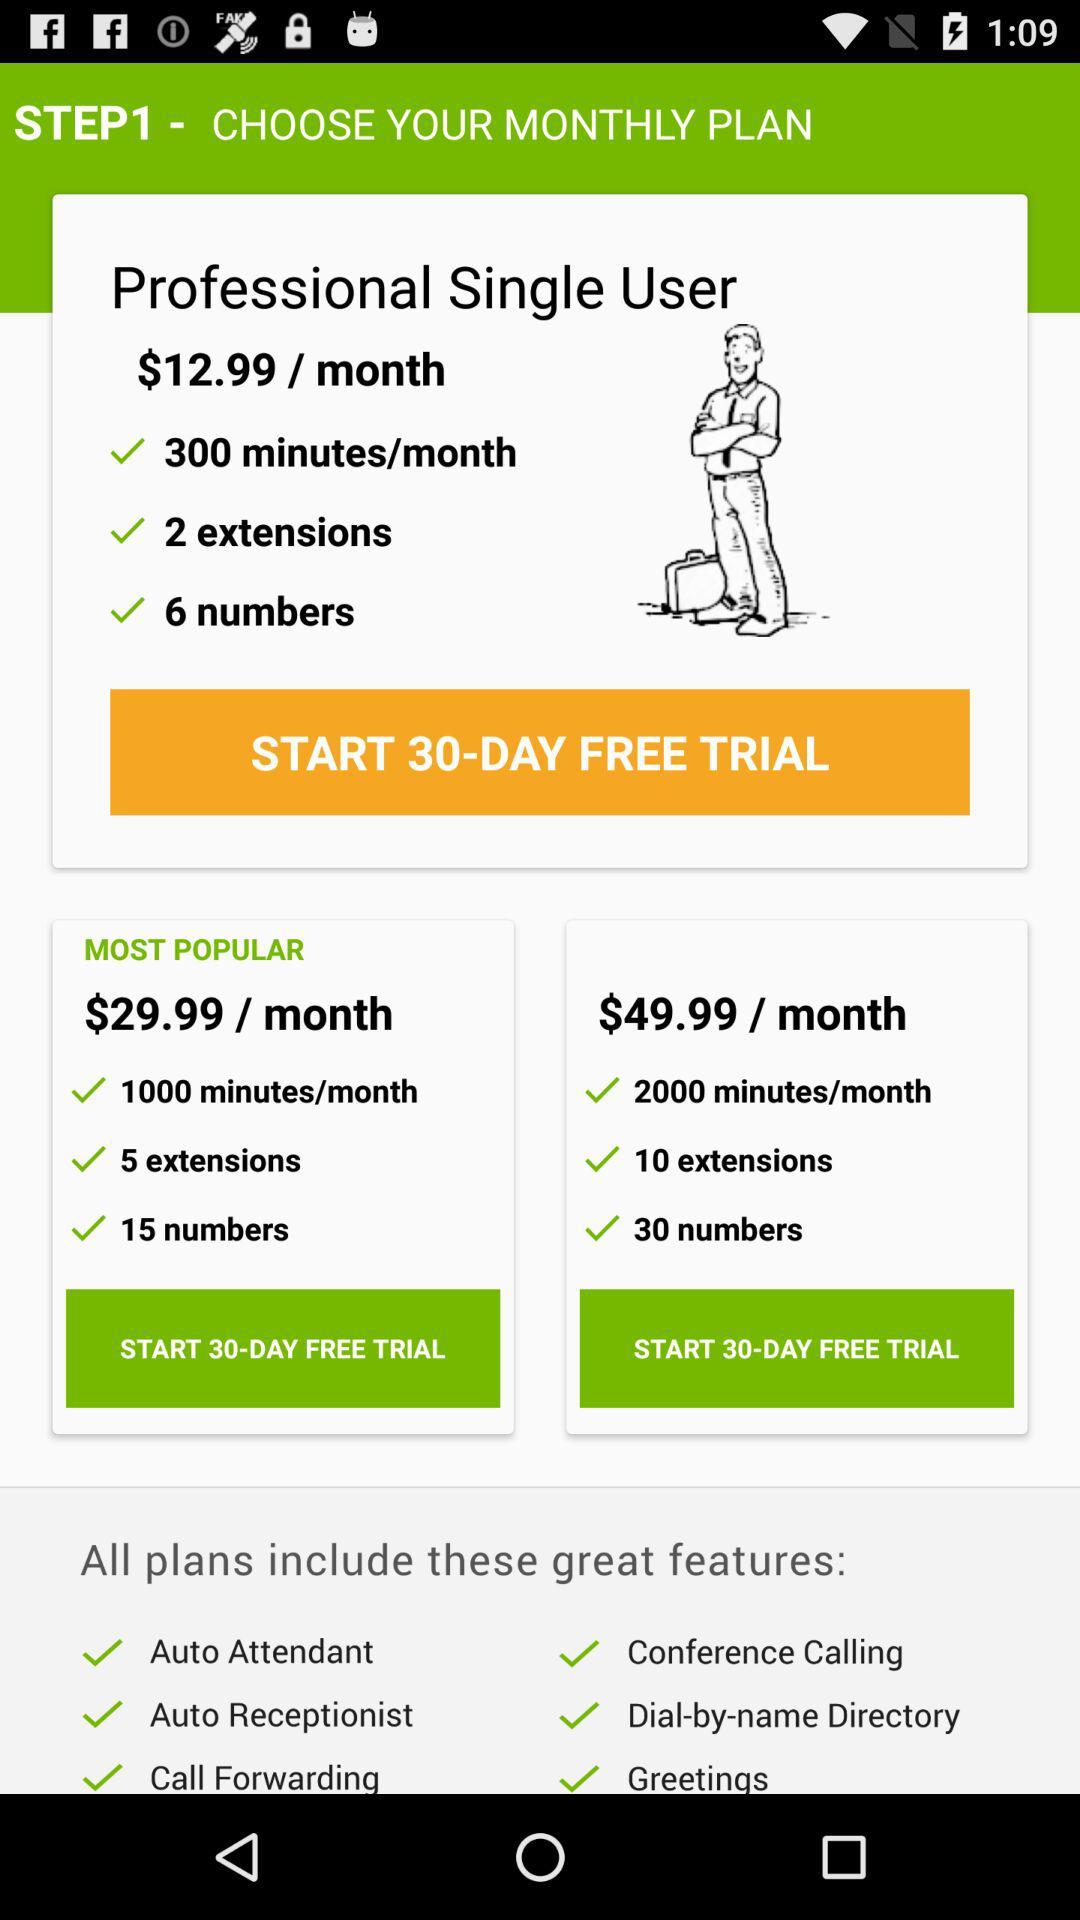For how many days is the free trial available? The free trial is available for 30 days. 